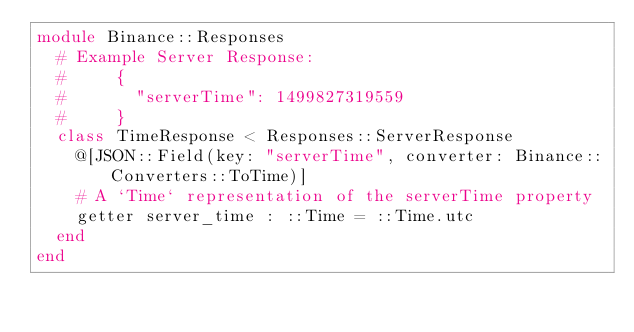Convert code to text. <code><loc_0><loc_0><loc_500><loc_500><_Crystal_>module Binance::Responses
  # Example Server Response:
  #     {
  #       "serverTime": 1499827319559
  #     }
  class TimeResponse < Responses::ServerResponse
    @[JSON::Field(key: "serverTime", converter: Binance::Converters::ToTime)]
    # A `Time` representation of the serverTime property
    getter server_time : ::Time = ::Time.utc
  end
end
</code> 